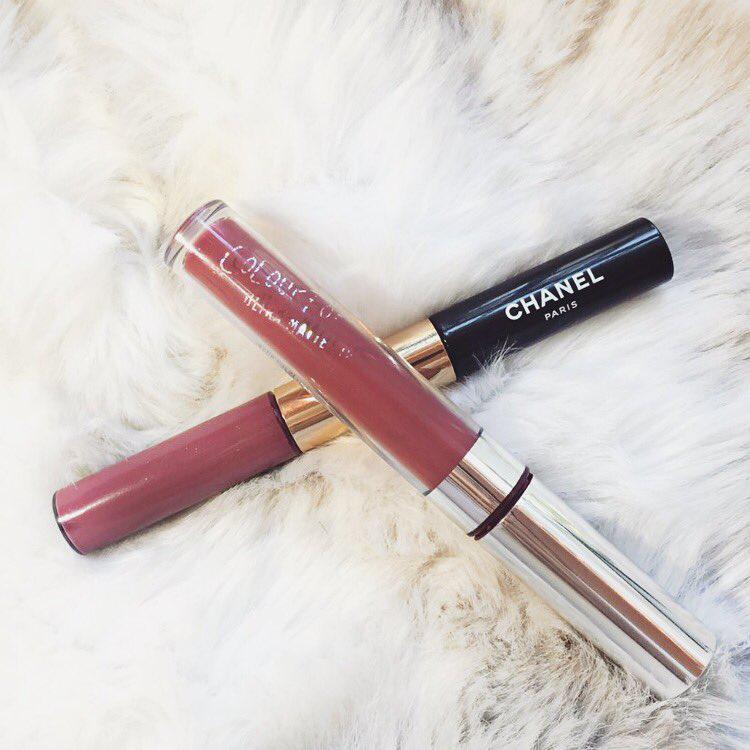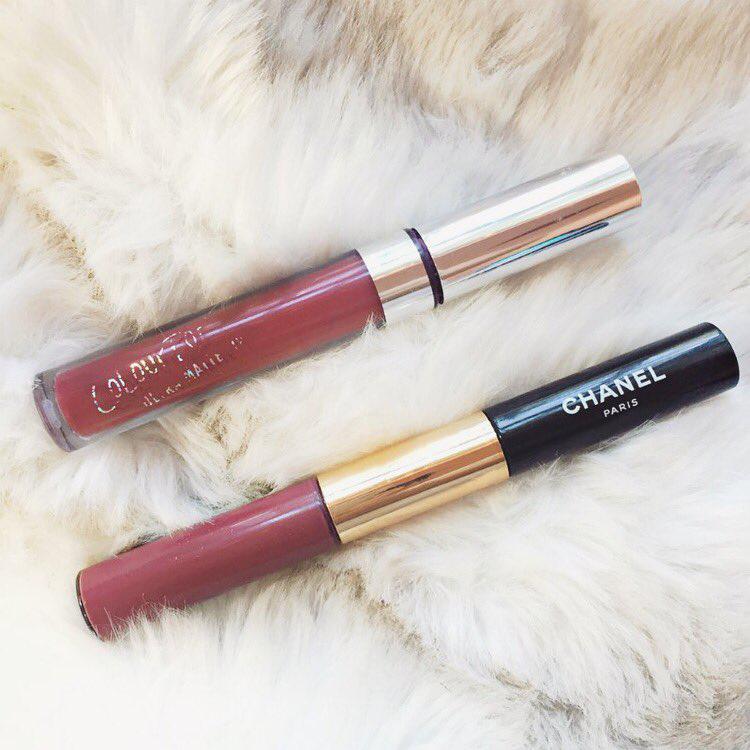The first image is the image on the left, the second image is the image on the right. Analyze the images presented: Is the assertion "there is a black bottle with an open lip gloss wand with a gold handle" valid? Answer yes or no. No. The first image is the image on the left, the second image is the image on the right. Assess this claim about the two images: "The left image contains an uncapped lipstick wand, and the right image includes at least one capped lip makeup.". Correct or not? Answer yes or no. No. 